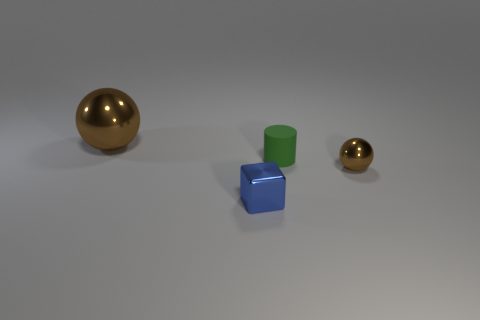Is there anything else that has the same material as the small green thing?
Give a very brief answer. No. Is there a brown metal thing to the left of the shiny sphere right of the big brown metallic object?
Offer a very short reply. Yes. Are there fewer cylinders that are on the right side of the big brown metal sphere than rubber objects that are on the left side of the metal block?
Ensure brevity in your answer.  No. Is there any other thing that has the same size as the blue shiny object?
Give a very brief answer. Yes. The rubber thing has what shape?
Keep it short and to the point. Cylinder. There is a object that is on the left side of the blue metal cube; what material is it?
Provide a succinct answer. Metal. How big is the brown metallic sphere in front of the metallic thing behind the small shiny object that is right of the tiny blue block?
Provide a succinct answer. Small. Is the material of the brown sphere in front of the green matte cylinder the same as the brown object on the left side of the blue block?
Offer a very short reply. Yes. What number of other objects are there of the same color as the small cube?
Offer a terse response. 0. How many things are brown spheres in front of the big brown shiny ball or metallic objects on the left side of the small blue thing?
Keep it short and to the point. 2. 